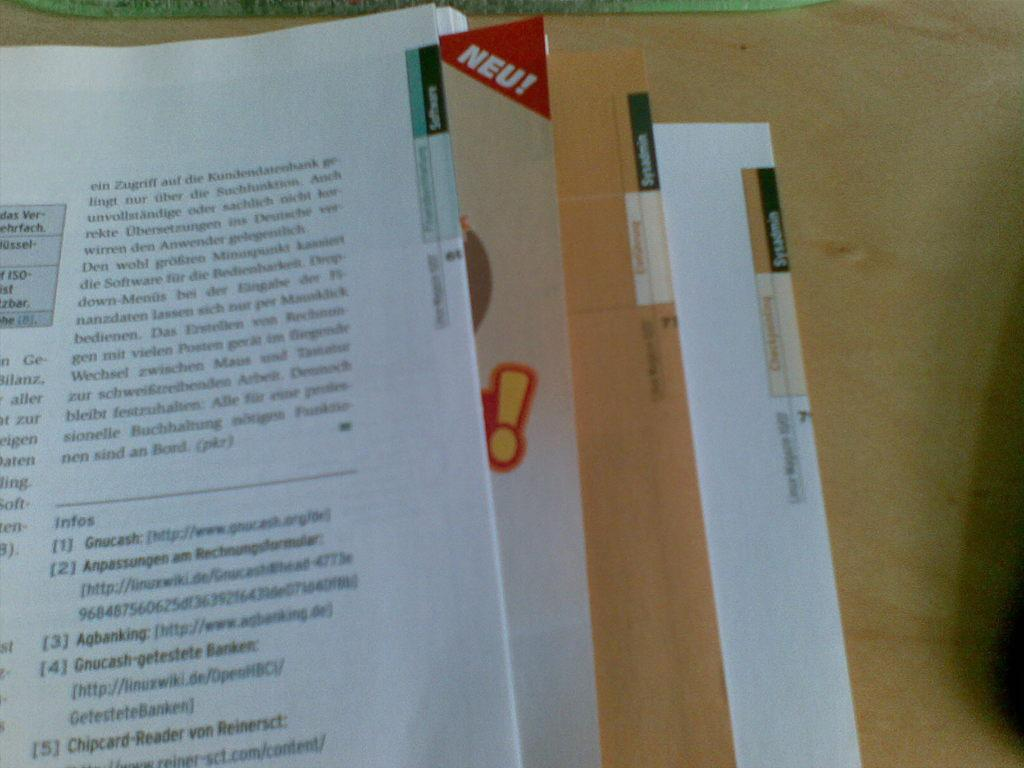<image>
Write a terse but informative summary of the picture. A book has the word NEU! displayed in a red triangle in the corner. 